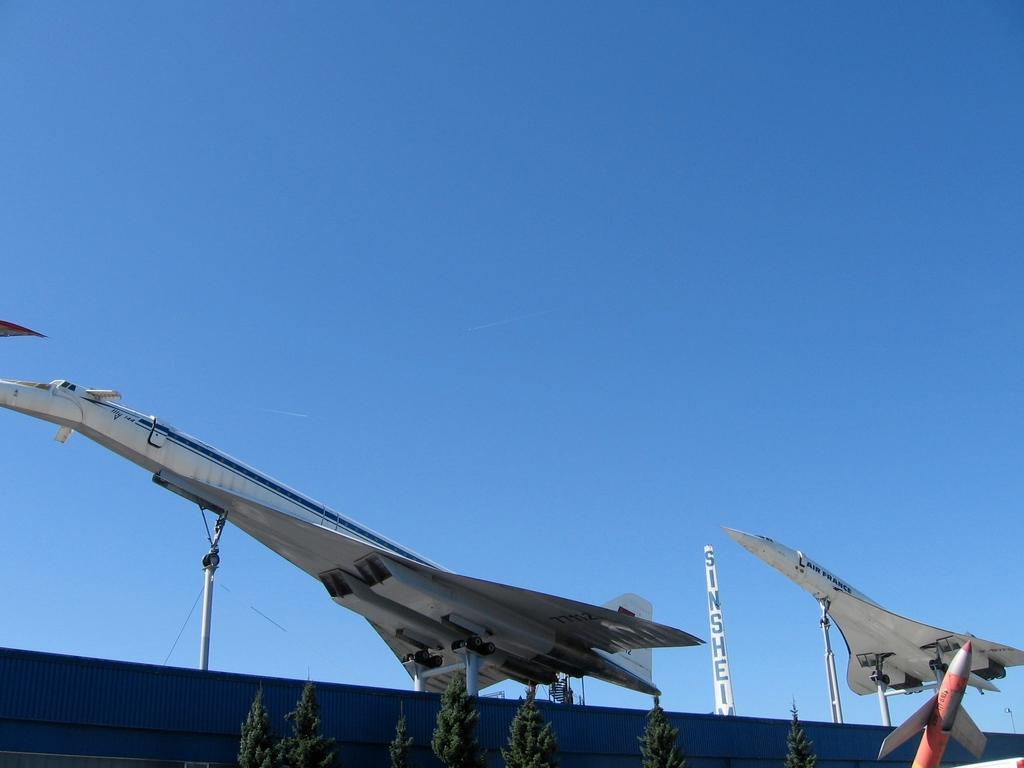What is the main subject of the image? The main subject of the image is planes. Can you describe any other objects or features in the image? Yes, there is an object with text in the image, as well as trees and the sky. What type of dress is the voice wearing in the image? There is no dress or voice present in the image; it features planes, an object with text, trees, and the sky. 